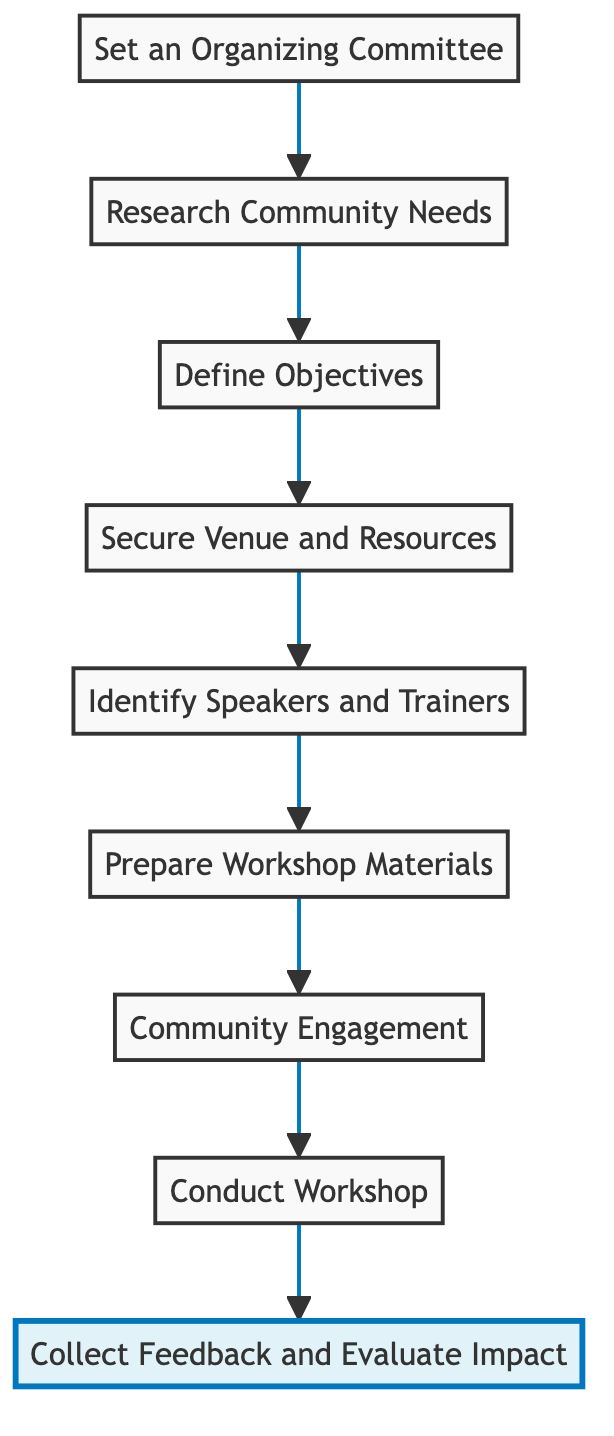What is the final step in the flowchart? The flowchart ends with the step labeled "Collect Feedback and Evaluate Impact," which is positioned at the top of the diagram.
Answer: Collect Feedback and Evaluate Impact How many steps are there in the diagram? The diagram contains a total of nine steps, starting from "Set an Organizing Committee" at the bottom to "Collect Feedback and Evaluate Impact" at the top.
Answer: 9 What is the first step in the process? The first step in the diagram is "Set an Organizing Committee," which is situated at the bottom of the flowchart.
Answer: Set an Organizing Committee Which step comes immediately before "Conduct Workshop"? The step that directly precedes "Conduct Workshop" is "Community Engagement," which is the step just before it in the flowchart.
Answer: Community Engagement What are the main components required for the "Conduct Workshop" step? Considering the preceding steps, the primary components for conducting the workshop are defined in the earlier steps, particularly engaging community members and securing venue and resources.
Answer: Community engagement, venue, and resources Which node marks the transition from planning to execution of the workshop? The transition from planning to execution occurs at "Conduct Workshop," as this is where the actual workshop activity takes place after all prior preparations.
Answer: Conduct Workshop How many components are involved in the preparation phase (steps before "Conduct Workshop")? The preparation phase includes steps "Set an Organizing Committee," "Research Community Needs," "Define Objectives," "Secure Venue and Resources," "Identify Speakers and Trainers," and "Prepare Workshop Materials," totaling six components.
Answer: 6 What step follows "Prepare Workshop Materials"? The step immediately following "Prepare Workshop Materials" is "Community Engagement," which involves inviting stakeholders to the workshop.
Answer: Community Engagement What is the role of "Define Objectives" in the workshop execution process? "Define Objectives" plays a crucial role as it sets clear goals for the workshop, aiming to enhance awareness about sustainable tourism, which frames the subsequent steps in the process.
Answer: Establish clear goals 